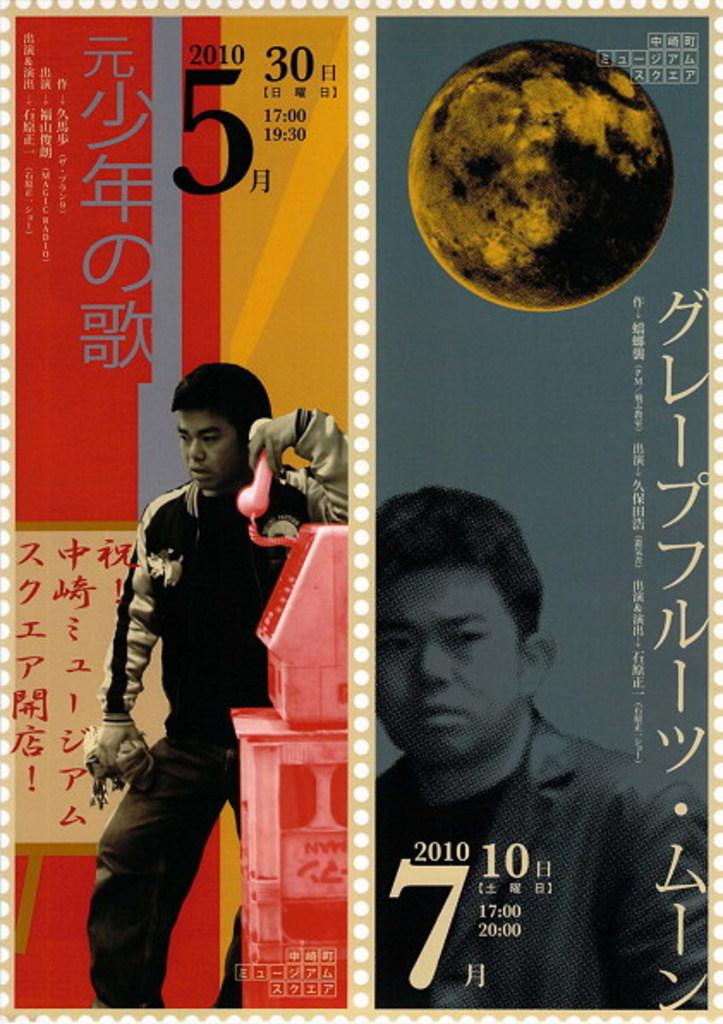What year is at the bottom?
Your answer should be very brief. 2010. 